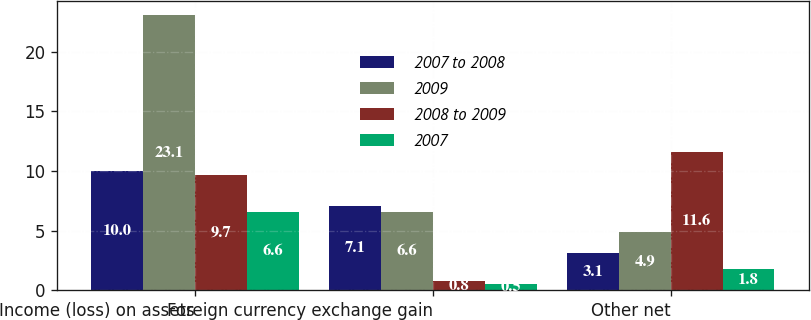Convert chart. <chart><loc_0><loc_0><loc_500><loc_500><stacked_bar_chart><ecel><fcel>Income (loss) on assets<fcel>Foreign currency exchange gain<fcel>Other net<nl><fcel>2007 to 2008<fcel>10<fcel>7.1<fcel>3.1<nl><fcel>2009<fcel>23.1<fcel>6.6<fcel>4.9<nl><fcel>2008 to 2009<fcel>9.7<fcel>0.8<fcel>11.6<nl><fcel>2007<fcel>6.6<fcel>0.5<fcel>1.8<nl></chart> 